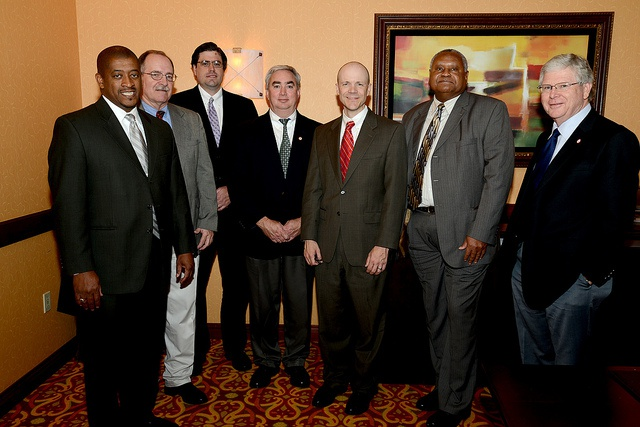Describe the objects in this image and their specific colors. I can see people in tan, black, maroon, lightgray, and darkgray tones, people in tan, black, gray, and navy tones, people in tan, black, gray, and maroon tones, people in tan, black, maroon, and brown tones, and people in tan, black, brown, lightgray, and salmon tones in this image. 